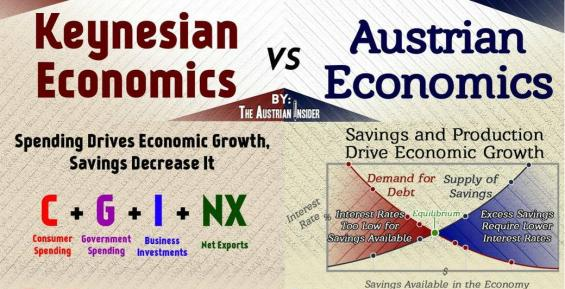List a handful of essential elements in this visual. According to Keynesian economics, spending is the key driver of economic growth. The comparison of Keynesian economic theory and Austrian economics is featured in the document. According to Austrian economics, savings and production are the two activities that drive economic growth. 